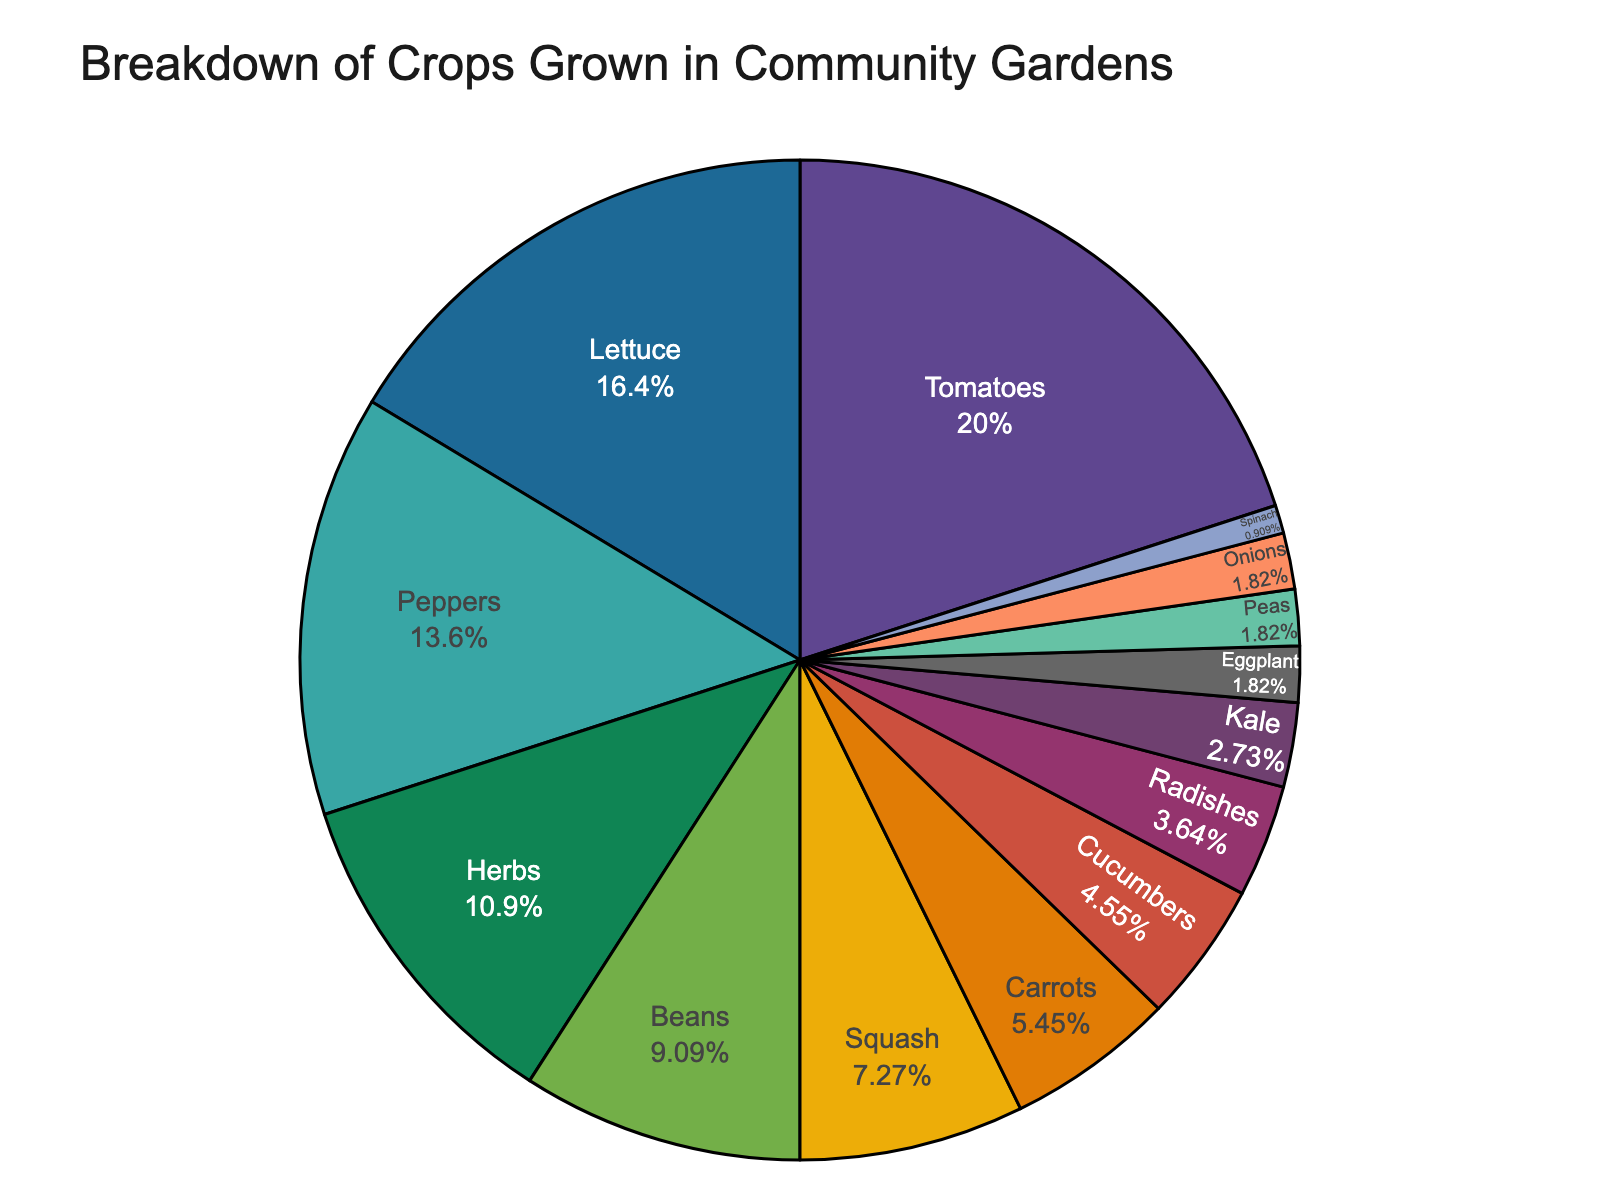Which crop has the highest percentage in the breakdown? The pie chart indicates which crop takes up the largest section of the circle. The crop listed as 22% is the highest.
Answer: Tomatoes Which three crops have the lowest percentages and what are their percentages? By identifying the smallest slices of the pie chart, you can see that the crops with the lowest percentages are listed with 2% or 1%. These crops are Eggplant (2%), Peas (2%), and Spinach (1%).
Answer: Eggplant (2%), Peas (2%), Spinach (1%) How much more percentage do Tomatoes have compared to the combined percentage of Onions and Spinach? The percentage for Tomatoes is 22%. Onions and Spinach are 2% and 1%, respectively. The combined percentage for Onions and Spinach is 3%. The difference is 22% - 3% = 19%.
Answer: 19% Which crops together make up approximately half (50%) of the total percentage? From the pie chart, adding the percentages in descending order until reaching or surpassing 50%, we start with Tomatoes (22%), Lettuce (18%), Peppers (15%). The sum is 22% + 18% + 15% = 55%, which is just above half.
Answer: Tomatoes, Lettuce, Peppers How does the percentage of Squash compare to Beans? The pie chart shows that Squash has 8% whereas Beans have 10%, so Beans have a higher percentage.
Answer: Beans have a higher percentage What is the cumulative percentage of Herbs, Carrots, and Cucumbers? Summing up the percentages of Herbs (12%), Carrots (6%), and Cucumbers (5%) gives 12% + 6% + 5% = 23%.
Answer: 23% Which crop has a smaller percentage than Cucumbers but larger than Radishes? Cucumbers are at 5%, and Radishes are at 4%. Couching crops that fall between these percentages leads us to Carrots at 6%.
Answer: Carrots Can you identify the crops that have a combined share greater than Lettuce but less than Tomatoes? Lettuce has 18%, and Tomatoes have 22%. To find crops with a combined percentage between, we can sum up smaller crops: Herbs (12%) + Beans (10%) = 22% (equal to Tomatoes), so the next smallest combination less than 22% and greater than Lettuce (18%) is Herbs (12%) + Squash (8%) = 20%.
Answer: Herbs, Squash Which crops together make up less than the total percentage of Peppers? Peppers have 15%. Identifying smaller crops and summing them: Kale (3%), Radishes (4%), Cucumbers (5%), and Carrots (6%) gives 3% + 4% + 5% + 6% = 18%, which is greater than Peppers. Therefore, a smaller combination must be Eggplant (2%), Peas (2%), Spinach (1%), and Radishes (4%) = 2% + 2% + 1% + 4% = 9% is less than Peppers.
Answer: Eggplant, Peas, Spinach, Radishes 